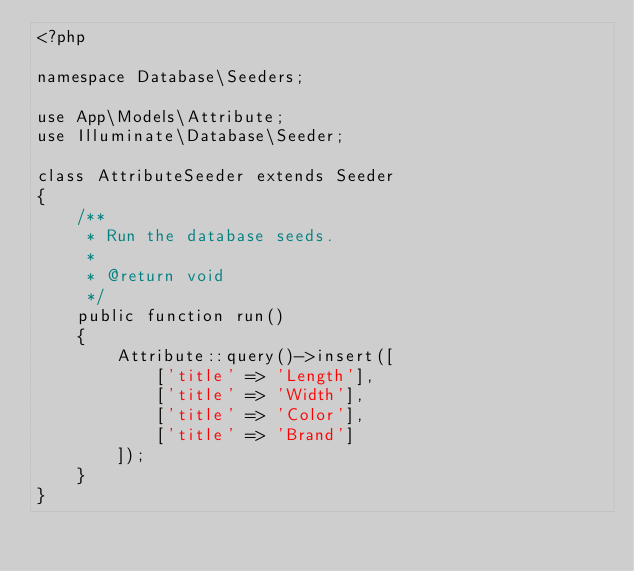<code> <loc_0><loc_0><loc_500><loc_500><_PHP_><?php

namespace Database\Seeders;

use App\Models\Attribute;
use Illuminate\Database\Seeder;

class AttributeSeeder extends Seeder
{
    /**
     * Run the database seeds.
     *
     * @return void
     */
    public function run()
    {
        Attribute::query()->insert([
            ['title' => 'Length'],
            ['title' => 'Width'],
            ['title' => 'Color'],
            ['title' => 'Brand']
        ]);
    }
}
</code> 